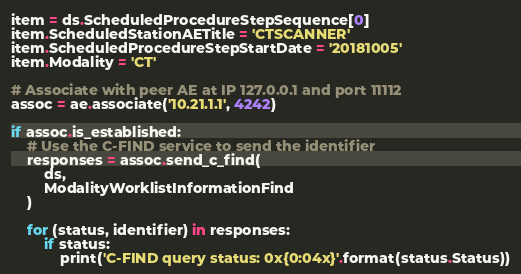Convert code to text. <code><loc_0><loc_0><loc_500><loc_500><_Python_>item = ds.ScheduledProcedureStepSequence[0]
item.ScheduledStationAETitle = 'CTSCANNER'
item.ScheduledProcedureStepStartDate = '20181005'
item.Modality = 'CT'

# Associate with peer AE at IP 127.0.0.1 and port 11112
assoc = ae.associate('10.21.1.1', 4242)

if assoc.is_established:
    # Use the C-FIND service to send the identifier
    responses = assoc.send_c_find(
        ds,
        ModalityWorklistInformationFind
    )

    for (status, identifier) in responses:
        if status:
            print('C-FIND query status: 0x{0:04x}'.format(status.Status))
</code> 